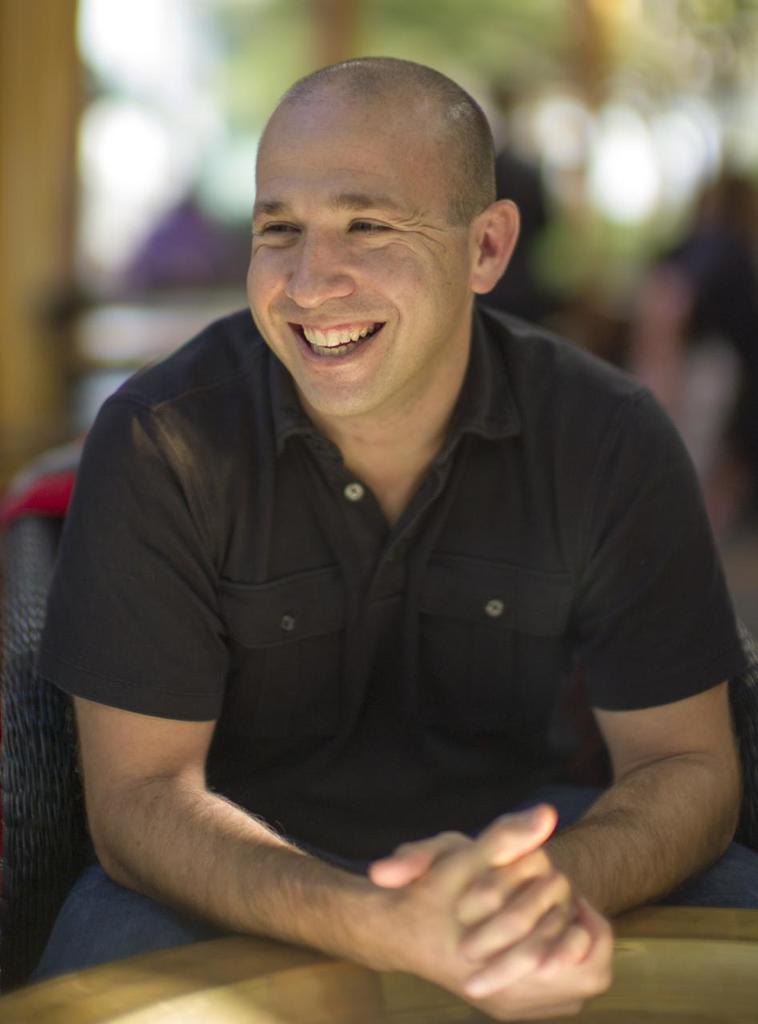What is the person in the image doing? The person is sitting on a chair in the image. What is the person's facial expression? The person is smiling. What type of object can be seen in the image? There is a wooden object in the image. Can you describe the background of the image? The background of the image is blurry. What type of whistle can be heard in the image? There is no whistle present in the image, and therefore no sound can be heard. 